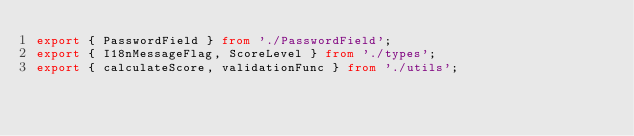Convert code to text. <code><loc_0><loc_0><loc_500><loc_500><_TypeScript_>export { PasswordField } from './PasswordField';
export { I18nMessageFlag, ScoreLevel } from './types';
export { calculateScore, validationFunc } from './utils';
</code> 